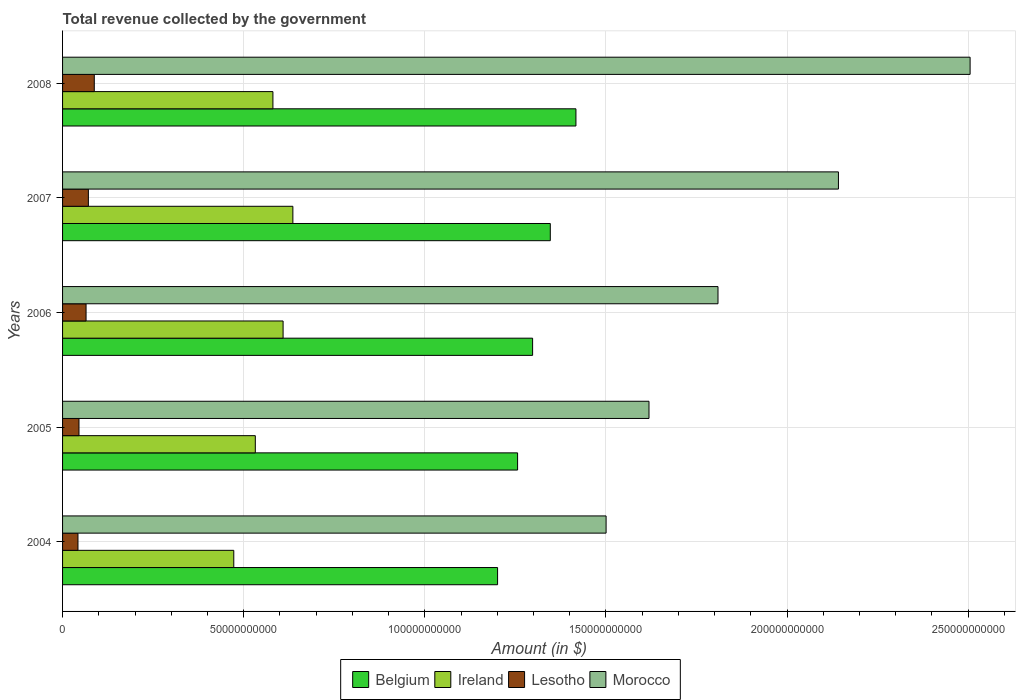How many different coloured bars are there?
Make the answer very short. 4. Are the number of bars on each tick of the Y-axis equal?
Make the answer very short. Yes. How many bars are there on the 3rd tick from the top?
Offer a terse response. 4. What is the total revenue collected by the government in Morocco in 2007?
Provide a succinct answer. 2.14e+11. Across all years, what is the maximum total revenue collected by the government in Lesotho?
Your answer should be compact. 8.76e+09. Across all years, what is the minimum total revenue collected by the government in Belgium?
Your response must be concise. 1.20e+11. What is the total total revenue collected by the government in Morocco in the graph?
Your response must be concise. 9.58e+11. What is the difference between the total revenue collected by the government in Ireland in 2006 and that in 2007?
Your answer should be very brief. -2.70e+09. What is the difference between the total revenue collected by the government in Belgium in 2005 and the total revenue collected by the government in Lesotho in 2007?
Your answer should be compact. 1.18e+11. What is the average total revenue collected by the government in Morocco per year?
Give a very brief answer. 1.92e+11. In the year 2008, what is the difference between the total revenue collected by the government in Ireland and total revenue collected by the government in Lesotho?
Your response must be concise. 4.93e+1. In how many years, is the total revenue collected by the government in Ireland greater than 120000000000 $?
Provide a succinct answer. 0. What is the ratio of the total revenue collected by the government in Morocco in 2005 to that in 2006?
Ensure brevity in your answer.  0.89. Is the difference between the total revenue collected by the government in Ireland in 2005 and 2007 greater than the difference between the total revenue collected by the government in Lesotho in 2005 and 2007?
Ensure brevity in your answer.  No. What is the difference between the highest and the second highest total revenue collected by the government in Morocco?
Give a very brief answer. 3.63e+1. What is the difference between the highest and the lowest total revenue collected by the government in Morocco?
Offer a terse response. 1.00e+11. In how many years, is the total revenue collected by the government in Belgium greater than the average total revenue collected by the government in Belgium taken over all years?
Provide a succinct answer. 2. Is it the case that in every year, the sum of the total revenue collected by the government in Belgium and total revenue collected by the government in Ireland is greater than the sum of total revenue collected by the government in Morocco and total revenue collected by the government in Lesotho?
Your answer should be very brief. Yes. What does the 1st bar from the top in 2008 represents?
Give a very brief answer. Morocco. What does the 3rd bar from the bottom in 2005 represents?
Offer a very short reply. Lesotho. How many bars are there?
Your answer should be very brief. 20. Are all the bars in the graph horizontal?
Ensure brevity in your answer.  Yes. How many years are there in the graph?
Your response must be concise. 5. What is the difference between two consecutive major ticks on the X-axis?
Keep it short and to the point. 5.00e+1. Where does the legend appear in the graph?
Provide a succinct answer. Bottom center. How many legend labels are there?
Offer a very short reply. 4. How are the legend labels stacked?
Offer a terse response. Horizontal. What is the title of the graph?
Offer a terse response. Total revenue collected by the government. Does "Eritrea" appear as one of the legend labels in the graph?
Provide a succinct answer. No. What is the label or title of the X-axis?
Your answer should be compact. Amount (in $). What is the label or title of the Y-axis?
Provide a succinct answer. Years. What is the Amount (in $) of Belgium in 2004?
Give a very brief answer. 1.20e+11. What is the Amount (in $) in Ireland in 2004?
Give a very brief answer. 4.73e+1. What is the Amount (in $) of Lesotho in 2004?
Keep it short and to the point. 4.25e+09. What is the Amount (in $) of Morocco in 2004?
Ensure brevity in your answer.  1.50e+11. What is the Amount (in $) in Belgium in 2005?
Your answer should be compact. 1.26e+11. What is the Amount (in $) in Ireland in 2005?
Your response must be concise. 5.32e+1. What is the Amount (in $) in Lesotho in 2005?
Give a very brief answer. 4.53e+09. What is the Amount (in $) of Morocco in 2005?
Keep it short and to the point. 1.62e+11. What is the Amount (in $) of Belgium in 2006?
Your answer should be very brief. 1.30e+11. What is the Amount (in $) in Ireland in 2006?
Keep it short and to the point. 6.09e+1. What is the Amount (in $) of Lesotho in 2006?
Give a very brief answer. 6.49e+09. What is the Amount (in $) of Morocco in 2006?
Keep it short and to the point. 1.81e+11. What is the Amount (in $) of Belgium in 2007?
Make the answer very short. 1.35e+11. What is the Amount (in $) of Ireland in 2007?
Make the answer very short. 6.36e+1. What is the Amount (in $) of Lesotho in 2007?
Keep it short and to the point. 7.13e+09. What is the Amount (in $) of Morocco in 2007?
Your answer should be very brief. 2.14e+11. What is the Amount (in $) of Belgium in 2008?
Your answer should be very brief. 1.42e+11. What is the Amount (in $) in Ireland in 2008?
Keep it short and to the point. 5.81e+1. What is the Amount (in $) in Lesotho in 2008?
Your answer should be very brief. 8.76e+09. What is the Amount (in $) in Morocco in 2008?
Ensure brevity in your answer.  2.51e+11. Across all years, what is the maximum Amount (in $) of Belgium?
Offer a terse response. 1.42e+11. Across all years, what is the maximum Amount (in $) in Ireland?
Your answer should be very brief. 6.36e+1. Across all years, what is the maximum Amount (in $) of Lesotho?
Ensure brevity in your answer.  8.76e+09. Across all years, what is the maximum Amount (in $) of Morocco?
Offer a very short reply. 2.51e+11. Across all years, what is the minimum Amount (in $) of Belgium?
Your answer should be very brief. 1.20e+11. Across all years, what is the minimum Amount (in $) of Ireland?
Provide a succinct answer. 4.73e+1. Across all years, what is the minimum Amount (in $) in Lesotho?
Your response must be concise. 4.25e+09. Across all years, what is the minimum Amount (in $) in Morocco?
Your response must be concise. 1.50e+11. What is the total Amount (in $) of Belgium in the graph?
Give a very brief answer. 6.52e+11. What is the total Amount (in $) of Ireland in the graph?
Make the answer very short. 2.83e+11. What is the total Amount (in $) in Lesotho in the graph?
Keep it short and to the point. 3.12e+1. What is the total Amount (in $) of Morocco in the graph?
Your response must be concise. 9.58e+11. What is the difference between the Amount (in $) in Belgium in 2004 and that in 2005?
Your response must be concise. -5.53e+09. What is the difference between the Amount (in $) of Ireland in 2004 and that in 2005?
Provide a succinct answer. -5.94e+09. What is the difference between the Amount (in $) of Lesotho in 2004 and that in 2005?
Make the answer very short. -2.81e+08. What is the difference between the Amount (in $) in Morocco in 2004 and that in 2005?
Offer a very short reply. -1.18e+1. What is the difference between the Amount (in $) in Belgium in 2004 and that in 2006?
Give a very brief answer. -9.67e+09. What is the difference between the Amount (in $) in Ireland in 2004 and that in 2006?
Offer a terse response. -1.36e+1. What is the difference between the Amount (in $) in Lesotho in 2004 and that in 2006?
Give a very brief answer. -2.23e+09. What is the difference between the Amount (in $) of Morocco in 2004 and that in 2006?
Keep it short and to the point. -3.09e+1. What is the difference between the Amount (in $) of Belgium in 2004 and that in 2007?
Provide a short and direct response. -1.46e+1. What is the difference between the Amount (in $) of Ireland in 2004 and that in 2007?
Offer a terse response. -1.63e+1. What is the difference between the Amount (in $) in Lesotho in 2004 and that in 2007?
Provide a succinct answer. -2.87e+09. What is the difference between the Amount (in $) of Morocco in 2004 and that in 2007?
Keep it short and to the point. -6.41e+1. What is the difference between the Amount (in $) of Belgium in 2004 and that in 2008?
Keep it short and to the point. -2.16e+1. What is the difference between the Amount (in $) in Ireland in 2004 and that in 2008?
Your response must be concise. -1.08e+1. What is the difference between the Amount (in $) in Lesotho in 2004 and that in 2008?
Provide a succinct answer. -4.50e+09. What is the difference between the Amount (in $) of Morocco in 2004 and that in 2008?
Give a very brief answer. -1.00e+11. What is the difference between the Amount (in $) in Belgium in 2005 and that in 2006?
Provide a short and direct response. -4.14e+09. What is the difference between the Amount (in $) of Ireland in 2005 and that in 2006?
Give a very brief answer. -7.67e+09. What is the difference between the Amount (in $) of Lesotho in 2005 and that in 2006?
Your response must be concise. -1.95e+09. What is the difference between the Amount (in $) of Morocco in 2005 and that in 2006?
Keep it short and to the point. -1.90e+1. What is the difference between the Amount (in $) of Belgium in 2005 and that in 2007?
Give a very brief answer. -9.03e+09. What is the difference between the Amount (in $) in Ireland in 2005 and that in 2007?
Your response must be concise. -1.04e+1. What is the difference between the Amount (in $) in Lesotho in 2005 and that in 2007?
Your answer should be compact. -2.59e+09. What is the difference between the Amount (in $) of Morocco in 2005 and that in 2007?
Give a very brief answer. -5.23e+1. What is the difference between the Amount (in $) in Belgium in 2005 and that in 2008?
Your answer should be compact. -1.61e+1. What is the difference between the Amount (in $) of Ireland in 2005 and that in 2008?
Your answer should be very brief. -4.86e+09. What is the difference between the Amount (in $) in Lesotho in 2005 and that in 2008?
Your answer should be compact. -4.22e+09. What is the difference between the Amount (in $) of Morocco in 2005 and that in 2008?
Keep it short and to the point. -8.86e+1. What is the difference between the Amount (in $) of Belgium in 2006 and that in 2007?
Offer a very short reply. -4.88e+09. What is the difference between the Amount (in $) in Ireland in 2006 and that in 2007?
Make the answer very short. -2.70e+09. What is the difference between the Amount (in $) of Lesotho in 2006 and that in 2007?
Offer a terse response. -6.38e+08. What is the difference between the Amount (in $) of Morocco in 2006 and that in 2007?
Make the answer very short. -3.32e+1. What is the difference between the Amount (in $) of Belgium in 2006 and that in 2008?
Give a very brief answer. -1.20e+1. What is the difference between the Amount (in $) in Ireland in 2006 and that in 2008?
Provide a succinct answer. 2.81e+09. What is the difference between the Amount (in $) of Lesotho in 2006 and that in 2008?
Ensure brevity in your answer.  -2.27e+09. What is the difference between the Amount (in $) of Morocco in 2006 and that in 2008?
Keep it short and to the point. -6.96e+1. What is the difference between the Amount (in $) of Belgium in 2007 and that in 2008?
Your response must be concise. -7.08e+09. What is the difference between the Amount (in $) of Ireland in 2007 and that in 2008?
Make the answer very short. 5.51e+09. What is the difference between the Amount (in $) in Lesotho in 2007 and that in 2008?
Give a very brief answer. -1.63e+09. What is the difference between the Amount (in $) of Morocco in 2007 and that in 2008?
Make the answer very short. -3.63e+1. What is the difference between the Amount (in $) of Belgium in 2004 and the Amount (in $) of Ireland in 2005?
Make the answer very short. 6.69e+1. What is the difference between the Amount (in $) of Belgium in 2004 and the Amount (in $) of Lesotho in 2005?
Keep it short and to the point. 1.16e+11. What is the difference between the Amount (in $) of Belgium in 2004 and the Amount (in $) of Morocco in 2005?
Your answer should be very brief. -4.18e+1. What is the difference between the Amount (in $) of Ireland in 2004 and the Amount (in $) of Lesotho in 2005?
Make the answer very short. 4.27e+1. What is the difference between the Amount (in $) in Ireland in 2004 and the Amount (in $) in Morocco in 2005?
Your answer should be very brief. -1.15e+11. What is the difference between the Amount (in $) in Lesotho in 2004 and the Amount (in $) in Morocco in 2005?
Your answer should be compact. -1.58e+11. What is the difference between the Amount (in $) in Belgium in 2004 and the Amount (in $) in Ireland in 2006?
Offer a very short reply. 5.92e+1. What is the difference between the Amount (in $) of Belgium in 2004 and the Amount (in $) of Lesotho in 2006?
Your answer should be very brief. 1.14e+11. What is the difference between the Amount (in $) of Belgium in 2004 and the Amount (in $) of Morocco in 2006?
Keep it short and to the point. -6.08e+1. What is the difference between the Amount (in $) in Ireland in 2004 and the Amount (in $) in Lesotho in 2006?
Your answer should be compact. 4.08e+1. What is the difference between the Amount (in $) of Ireland in 2004 and the Amount (in $) of Morocco in 2006?
Your answer should be very brief. -1.34e+11. What is the difference between the Amount (in $) of Lesotho in 2004 and the Amount (in $) of Morocco in 2006?
Make the answer very short. -1.77e+11. What is the difference between the Amount (in $) in Belgium in 2004 and the Amount (in $) in Ireland in 2007?
Offer a very short reply. 5.65e+1. What is the difference between the Amount (in $) in Belgium in 2004 and the Amount (in $) in Lesotho in 2007?
Your answer should be compact. 1.13e+11. What is the difference between the Amount (in $) of Belgium in 2004 and the Amount (in $) of Morocco in 2007?
Offer a terse response. -9.41e+1. What is the difference between the Amount (in $) of Ireland in 2004 and the Amount (in $) of Lesotho in 2007?
Your answer should be compact. 4.01e+1. What is the difference between the Amount (in $) in Ireland in 2004 and the Amount (in $) in Morocco in 2007?
Keep it short and to the point. -1.67e+11. What is the difference between the Amount (in $) in Lesotho in 2004 and the Amount (in $) in Morocco in 2007?
Give a very brief answer. -2.10e+11. What is the difference between the Amount (in $) of Belgium in 2004 and the Amount (in $) of Ireland in 2008?
Ensure brevity in your answer.  6.20e+1. What is the difference between the Amount (in $) of Belgium in 2004 and the Amount (in $) of Lesotho in 2008?
Keep it short and to the point. 1.11e+11. What is the difference between the Amount (in $) of Belgium in 2004 and the Amount (in $) of Morocco in 2008?
Provide a short and direct response. -1.30e+11. What is the difference between the Amount (in $) in Ireland in 2004 and the Amount (in $) in Lesotho in 2008?
Ensure brevity in your answer.  3.85e+1. What is the difference between the Amount (in $) in Ireland in 2004 and the Amount (in $) in Morocco in 2008?
Give a very brief answer. -2.03e+11. What is the difference between the Amount (in $) of Lesotho in 2004 and the Amount (in $) of Morocco in 2008?
Provide a succinct answer. -2.46e+11. What is the difference between the Amount (in $) in Belgium in 2005 and the Amount (in $) in Ireland in 2006?
Provide a succinct answer. 6.47e+1. What is the difference between the Amount (in $) of Belgium in 2005 and the Amount (in $) of Lesotho in 2006?
Ensure brevity in your answer.  1.19e+11. What is the difference between the Amount (in $) of Belgium in 2005 and the Amount (in $) of Morocco in 2006?
Offer a very short reply. -5.53e+1. What is the difference between the Amount (in $) of Ireland in 2005 and the Amount (in $) of Lesotho in 2006?
Your answer should be compact. 4.67e+1. What is the difference between the Amount (in $) in Ireland in 2005 and the Amount (in $) in Morocco in 2006?
Offer a terse response. -1.28e+11. What is the difference between the Amount (in $) in Lesotho in 2005 and the Amount (in $) in Morocco in 2006?
Your answer should be very brief. -1.76e+11. What is the difference between the Amount (in $) in Belgium in 2005 and the Amount (in $) in Ireland in 2007?
Ensure brevity in your answer.  6.20e+1. What is the difference between the Amount (in $) in Belgium in 2005 and the Amount (in $) in Lesotho in 2007?
Provide a short and direct response. 1.18e+11. What is the difference between the Amount (in $) in Belgium in 2005 and the Amount (in $) in Morocco in 2007?
Offer a terse response. -8.86e+1. What is the difference between the Amount (in $) in Ireland in 2005 and the Amount (in $) in Lesotho in 2007?
Ensure brevity in your answer.  4.61e+1. What is the difference between the Amount (in $) of Ireland in 2005 and the Amount (in $) of Morocco in 2007?
Your response must be concise. -1.61e+11. What is the difference between the Amount (in $) in Lesotho in 2005 and the Amount (in $) in Morocco in 2007?
Your answer should be compact. -2.10e+11. What is the difference between the Amount (in $) in Belgium in 2005 and the Amount (in $) in Ireland in 2008?
Offer a terse response. 6.75e+1. What is the difference between the Amount (in $) of Belgium in 2005 and the Amount (in $) of Lesotho in 2008?
Provide a short and direct response. 1.17e+11. What is the difference between the Amount (in $) in Belgium in 2005 and the Amount (in $) in Morocco in 2008?
Keep it short and to the point. -1.25e+11. What is the difference between the Amount (in $) of Ireland in 2005 and the Amount (in $) of Lesotho in 2008?
Your answer should be very brief. 4.44e+1. What is the difference between the Amount (in $) of Ireland in 2005 and the Amount (in $) of Morocco in 2008?
Make the answer very short. -1.97e+11. What is the difference between the Amount (in $) in Lesotho in 2005 and the Amount (in $) in Morocco in 2008?
Provide a succinct answer. -2.46e+11. What is the difference between the Amount (in $) of Belgium in 2006 and the Amount (in $) of Ireland in 2007?
Make the answer very short. 6.62e+1. What is the difference between the Amount (in $) of Belgium in 2006 and the Amount (in $) of Lesotho in 2007?
Your answer should be very brief. 1.23e+11. What is the difference between the Amount (in $) of Belgium in 2006 and the Amount (in $) of Morocco in 2007?
Keep it short and to the point. -8.44e+1. What is the difference between the Amount (in $) of Ireland in 2006 and the Amount (in $) of Lesotho in 2007?
Make the answer very short. 5.37e+1. What is the difference between the Amount (in $) of Ireland in 2006 and the Amount (in $) of Morocco in 2007?
Your answer should be compact. -1.53e+11. What is the difference between the Amount (in $) of Lesotho in 2006 and the Amount (in $) of Morocco in 2007?
Keep it short and to the point. -2.08e+11. What is the difference between the Amount (in $) of Belgium in 2006 and the Amount (in $) of Ireland in 2008?
Your response must be concise. 7.17e+1. What is the difference between the Amount (in $) in Belgium in 2006 and the Amount (in $) in Lesotho in 2008?
Your response must be concise. 1.21e+11. What is the difference between the Amount (in $) in Belgium in 2006 and the Amount (in $) in Morocco in 2008?
Keep it short and to the point. -1.21e+11. What is the difference between the Amount (in $) in Ireland in 2006 and the Amount (in $) in Lesotho in 2008?
Offer a very short reply. 5.21e+1. What is the difference between the Amount (in $) in Ireland in 2006 and the Amount (in $) in Morocco in 2008?
Keep it short and to the point. -1.90e+11. What is the difference between the Amount (in $) of Lesotho in 2006 and the Amount (in $) of Morocco in 2008?
Offer a very short reply. -2.44e+11. What is the difference between the Amount (in $) in Belgium in 2007 and the Amount (in $) in Ireland in 2008?
Offer a terse response. 7.66e+1. What is the difference between the Amount (in $) in Belgium in 2007 and the Amount (in $) in Lesotho in 2008?
Provide a succinct answer. 1.26e+11. What is the difference between the Amount (in $) of Belgium in 2007 and the Amount (in $) of Morocco in 2008?
Ensure brevity in your answer.  -1.16e+11. What is the difference between the Amount (in $) of Ireland in 2007 and the Amount (in $) of Lesotho in 2008?
Your answer should be very brief. 5.48e+1. What is the difference between the Amount (in $) in Ireland in 2007 and the Amount (in $) in Morocco in 2008?
Provide a succinct answer. -1.87e+11. What is the difference between the Amount (in $) in Lesotho in 2007 and the Amount (in $) in Morocco in 2008?
Your answer should be very brief. -2.43e+11. What is the average Amount (in $) of Belgium per year?
Your response must be concise. 1.30e+11. What is the average Amount (in $) of Ireland per year?
Provide a succinct answer. 5.66e+1. What is the average Amount (in $) of Lesotho per year?
Offer a terse response. 6.23e+09. What is the average Amount (in $) of Morocco per year?
Give a very brief answer. 1.92e+11. In the year 2004, what is the difference between the Amount (in $) in Belgium and Amount (in $) in Ireland?
Make the answer very short. 7.28e+1. In the year 2004, what is the difference between the Amount (in $) in Belgium and Amount (in $) in Lesotho?
Provide a succinct answer. 1.16e+11. In the year 2004, what is the difference between the Amount (in $) of Belgium and Amount (in $) of Morocco?
Your answer should be compact. -3.00e+1. In the year 2004, what is the difference between the Amount (in $) of Ireland and Amount (in $) of Lesotho?
Make the answer very short. 4.30e+1. In the year 2004, what is the difference between the Amount (in $) in Ireland and Amount (in $) in Morocco?
Your response must be concise. -1.03e+11. In the year 2004, what is the difference between the Amount (in $) of Lesotho and Amount (in $) of Morocco?
Provide a short and direct response. -1.46e+11. In the year 2005, what is the difference between the Amount (in $) of Belgium and Amount (in $) of Ireland?
Your answer should be very brief. 7.24e+1. In the year 2005, what is the difference between the Amount (in $) of Belgium and Amount (in $) of Lesotho?
Make the answer very short. 1.21e+11. In the year 2005, what is the difference between the Amount (in $) of Belgium and Amount (in $) of Morocco?
Your response must be concise. -3.63e+1. In the year 2005, what is the difference between the Amount (in $) in Ireland and Amount (in $) in Lesotho?
Keep it short and to the point. 4.87e+1. In the year 2005, what is the difference between the Amount (in $) in Ireland and Amount (in $) in Morocco?
Make the answer very short. -1.09e+11. In the year 2005, what is the difference between the Amount (in $) in Lesotho and Amount (in $) in Morocco?
Offer a very short reply. -1.57e+11. In the year 2006, what is the difference between the Amount (in $) of Belgium and Amount (in $) of Ireland?
Your answer should be compact. 6.89e+1. In the year 2006, what is the difference between the Amount (in $) in Belgium and Amount (in $) in Lesotho?
Provide a short and direct response. 1.23e+11. In the year 2006, what is the difference between the Amount (in $) of Belgium and Amount (in $) of Morocco?
Provide a succinct answer. -5.12e+1. In the year 2006, what is the difference between the Amount (in $) in Ireland and Amount (in $) in Lesotho?
Your answer should be compact. 5.44e+1. In the year 2006, what is the difference between the Amount (in $) in Ireland and Amount (in $) in Morocco?
Provide a succinct answer. -1.20e+11. In the year 2006, what is the difference between the Amount (in $) in Lesotho and Amount (in $) in Morocco?
Your answer should be compact. -1.74e+11. In the year 2007, what is the difference between the Amount (in $) in Belgium and Amount (in $) in Ireland?
Give a very brief answer. 7.11e+1. In the year 2007, what is the difference between the Amount (in $) of Belgium and Amount (in $) of Lesotho?
Your response must be concise. 1.28e+11. In the year 2007, what is the difference between the Amount (in $) of Belgium and Amount (in $) of Morocco?
Ensure brevity in your answer.  -7.95e+1. In the year 2007, what is the difference between the Amount (in $) in Ireland and Amount (in $) in Lesotho?
Provide a succinct answer. 5.64e+1. In the year 2007, what is the difference between the Amount (in $) in Ireland and Amount (in $) in Morocco?
Offer a very short reply. -1.51e+11. In the year 2007, what is the difference between the Amount (in $) of Lesotho and Amount (in $) of Morocco?
Give a very brief answer. -2.07e+11. In the year 2008, what is the difference between the Amount (in $) in Belgium and Amount (in $) in Ireland?
Your response must be concise. 8.36e+1. In the year 2008, what is the difference between the Amount (in $) of Belgium and Amount (in $) of Lesotho?
Provide a succinct answer. 1.33e+11. In the year 2008, what is the difference between the Amount (in $) of Belgium and Amount (in $) of Morocco?
Provide a short and direct response. -1.09e+11. In the year 2008, what is the difference between the Amount (in $) of Ireland and Amount (in $) of Lesotho?
Keep it short and to the point. 4.93e+1. In the year 2008, what is the difference between the Amount (in $) in Ireland and Amount (in $) in Morocco?
Your answer should be compact. -1.92e+11. In the year 2008, what is the difference between the Amount (in $) of Lesotho and Amount (in $) of Morocco?
Give a very brief answer. -2.42e+11. What is the ratio of the Amount (in $) of Belgium in 2004 to that in 2005?
Give a very brief answer. 0.96. What is the ratio of the Amount (in $) of Ireland in 2004 to that in 2005?
Provide a succinct answer. 0.89. What is the ratio of the Amount (in $) in Lesotho in 2004 to that in 2005?
Give a very brief answer. 0.94. What is the ratio of the Amount (in $) of Morocco in 2004 to that in 2005?
Your response must be concise. 0.93. What is the ratio of the Amount (in $) in Belgium in 2004 to that in 2006?
Your answer should be compact. 0.93. What is the ratio of the Amount (in $) in Ireland in 2004 to that in 2006?
Your answer should be very brief. 0.78. What is the ratio of the Amount (in $) of Lesotho in 2004 to that in 2006?
Give a very brief answer. 0.66. What is the ratio of the Amount (in $) in Morocco in 2004 to that in 2006?
Offer a very short reply. 0.83. What is the ratio of the Amount (in $) of Belgium in 2004 to that in 2007?
Make the answer very short. 0.89. What is the ratio of the Amount (in $) of Ireland in 2004 to that in 2007?
Offer a terse response. 0.74. What is the ratio of the Amount (in $) of Lesotho in 2004 to that in 2007?
Your answer should be compact. 0.6. What is the ratio of the Amount (in $) of Morocco in 2004 to that in 2007?
Your response must be concise. 0.7. What is the ratio of the Amount (in $) in Belgium in 2004 to that in 2008?
Give a very brief answer. 0.85. What is the ratio of the Amount (in $) of Ireland in 2004 to that in 2008?
Offer a terse response. 0.81. What is the ratio of the Amount (in $) in Lesotho in 2004 to that in 2008?
Keep it short and to the point. 0.49. What is the ratio of the Amount (in $) of Morocco in 2004 to that in 2008?
Give a very brief answer. 0.6. What is the ratio of the Amount (in $) of Belgium in 2005 to that in 2006?
Make the answer very short. 0.97. What is the ratio of the Amount (in $) in Ireland in 2005 to that in 2006?
Offer a terse response. 0.87. What is the ratio of the Amount (in $) of Lesotho in 2005 to that in 2006?
Your response must be concise. 0.7. What is the ratio of the Amount (in $) in Morocco in 2005 to that in 2006?
Your answer should be very brief. 0.89. What is the ratio of the Amount (in $) of Belgium in 2005 to that in 2007?
Offer a very short reply. 0.93. What is the ratio of the Amount (in $) in Ireland in 2005 to that in 2007?
Provide a succinct answer. 0.84. What is the ratio of the Amount (in $) in Lesotho in 2005 to that in 2007?
Make the answer very short. 0.64. What is the ratio of the Amount (in $) in Morocco in 2005 to that in 2007?
Offer a terse response. 0.76. What is the ratio of the Amount (in $) of Belgium in 2005 to that in 2008?
Your response must be concise. 0.89. What is the ratio of the Amount (in $) in Ireland in 2005 to that in 2008?
Provide a short and direct response. 0.92. What is the ratio of the Amount (in $) in Lesotho in 2005 to that in 2008?
Your answer should be very brief. 0.52. What is the ratio of the Amount (in $) of Morocco in 2005 to that in 2008?
Offer a very short reply. 0.65. What is the ratio of the Amount (in $) in Belgium in 2006 to that in 2007?
Provide a short and direct response. 0.96. What is the ratio of the Amount (in $) of Ireland in 2006 to that in 2007?
Provide a short and direct response. 0.96. What is the ratio of the Amount (in $) of Lesotho in 2006 to that in 2007?
Give a very brief answer. 0.91. What is the ratio of the Amount (in $) of Morocco in 2006 to that in 2007?
Provide a succinct answer. 0.84. What is the ratio of the Amount (in $) of Belgium in 2006 to that in 2008?
Give a very brief answer. 0.92. What is the ratio of the Amount (in $) in Ireland in 2006 to that in 2008?
Your answer should be compact. 1.05. What is the ratio of the Amount (in $) in Lesotho in 2006 to that in 2008?
Keep it short and to the point. 0.74. What is the ratio of the Amount (in $) of Morocco in 2006 to that in 2008?
Ensure brevity in your answer.  0.72. What is the ratio of the Amount (in $) of Belgium in 2007 to that in 2008?
Offer a terse response. 0.95. What is the ratio of the Amount (in $) of Ireland in 2007 to that in 2008?
Make the answer very short. 1.09. What is the ratio of the Amount (in $) of Lesotho in 2007 to that in 2008?
Make the answer very short. 0.81. What is the ratio of the Amount (in $) of Morocco in 2007 to that in 2008?
Offer a very short reply. 0.85. What is the difference between the highest and the second highest Amount (in $) in Belgium?
Provide a succinct answer. 7.08e+09. What is the difference between the highest and the second highest Amount (in $) in Ireland?
Give a very brief answer. 2.70e+09. What is the difference between the highest and the second highest Amount (in $) in Lesotho?
Your answer should be compact. 1.63e+09. What is the difference between the highest and the second highest Amount (in $) in Morocco?
Your response must be concise. 3.63e+1. What is the difference between the highest and the lowest Amount (in $) of Belgium?
Ensure brevity in your answer.  2.16e+1. What is the difference between the highest and the lowest Amount (in $) in Ireland?
Your answer should be very brief. 1.63e+1. What is the difference between the highest and the lowest Amount (in $) of Lesotho?
Offer a terse response. 4.50e+09. What is the difference between the highest and the lowest Amount (in $) of Morocco?
Offer a very short reply. 1.00e+11. 